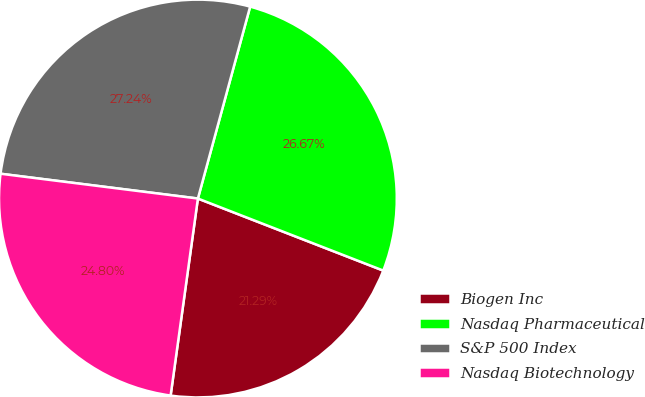<chart> <loc_0><loc_0><loc_500><loc_500><pie_chart><fcel>Biogen Inc<fcel>Nasdaq Pharmaceutical<fcel>S&P 500 Index<fcel>Nasdaq Biotechnology<nl><fcel>21.29%<fcel>26.67%<fcel>27.24%<fcel>24.8%<nl></chart> 